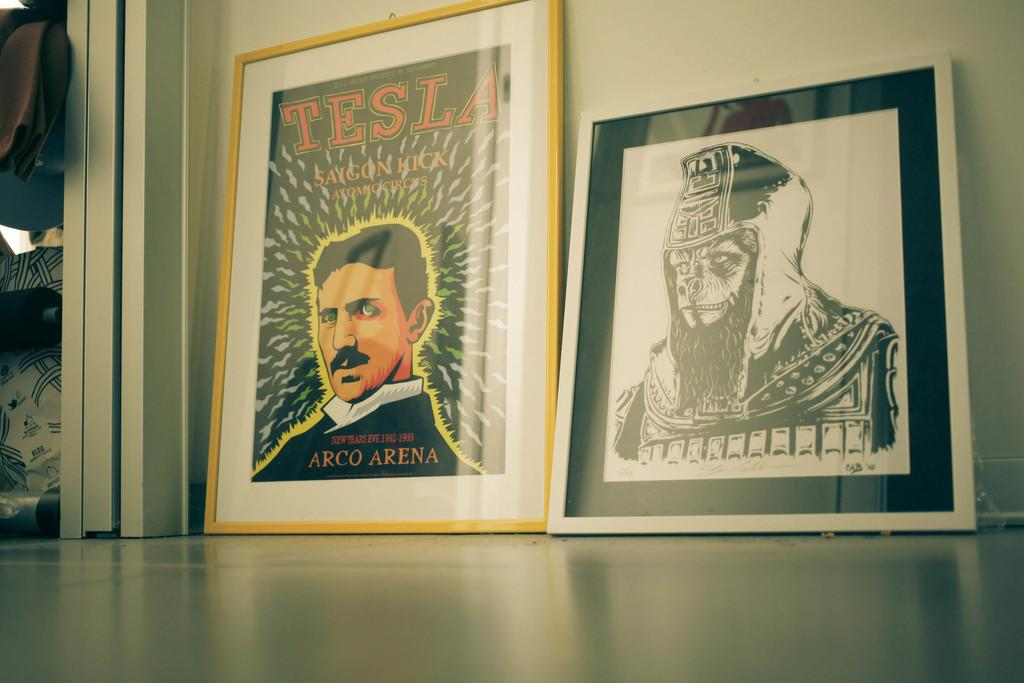<image>
Write a terse but informative summary of the picture. A colored poster with Tesla at the top its next to a black and white print. 